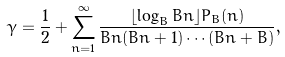Convert formula to latex. <formula><loc_0><loc_0><loc_500><loc_500>\gamma = \frac { 1 } { 2 } + \sum _ { n = 1 } ^ { \infty } \frac { \lfloor \log _ { B } B n \rfloor P _ { B } ( n ) } { B n ( B n + 1 ) \cdots ( B n + B ) } ,</formula> 